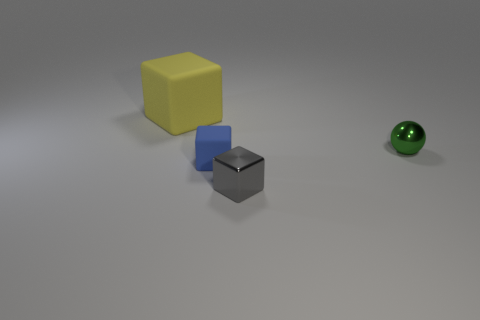Add 1 red shiny blocks. How many objects exist? 5 Subtract all spheres. How many objects are left? 3 Add 4 big yellow blocks. How many big yellow blocks exist? 5 Subtract 0 brown cylinders. How many objects are left? 4 Subtract all rubber cubes. Subtract all small yellow matte cylinders. How many objects are left? 2 Add 2 small blue rubber cubes. How many small blue rubber cubes are left? 3 